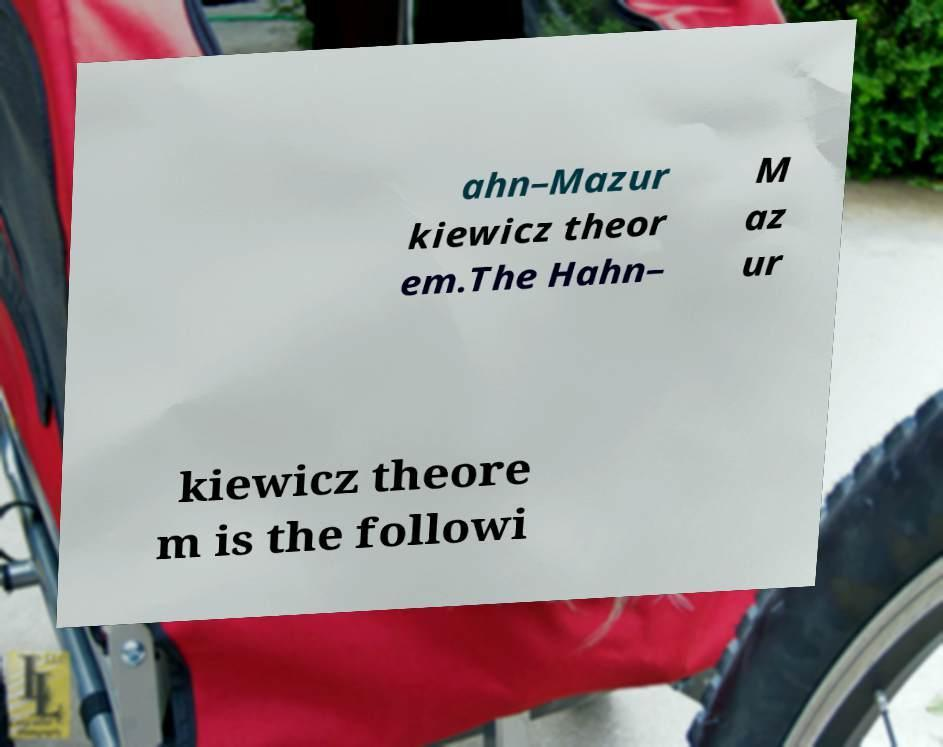Could you assist in decoding the text presented in this image and type it out clearly? ahn–Mazur kiewicz theor em.The Hahn– M az ur kiewicz theore m is the followi 